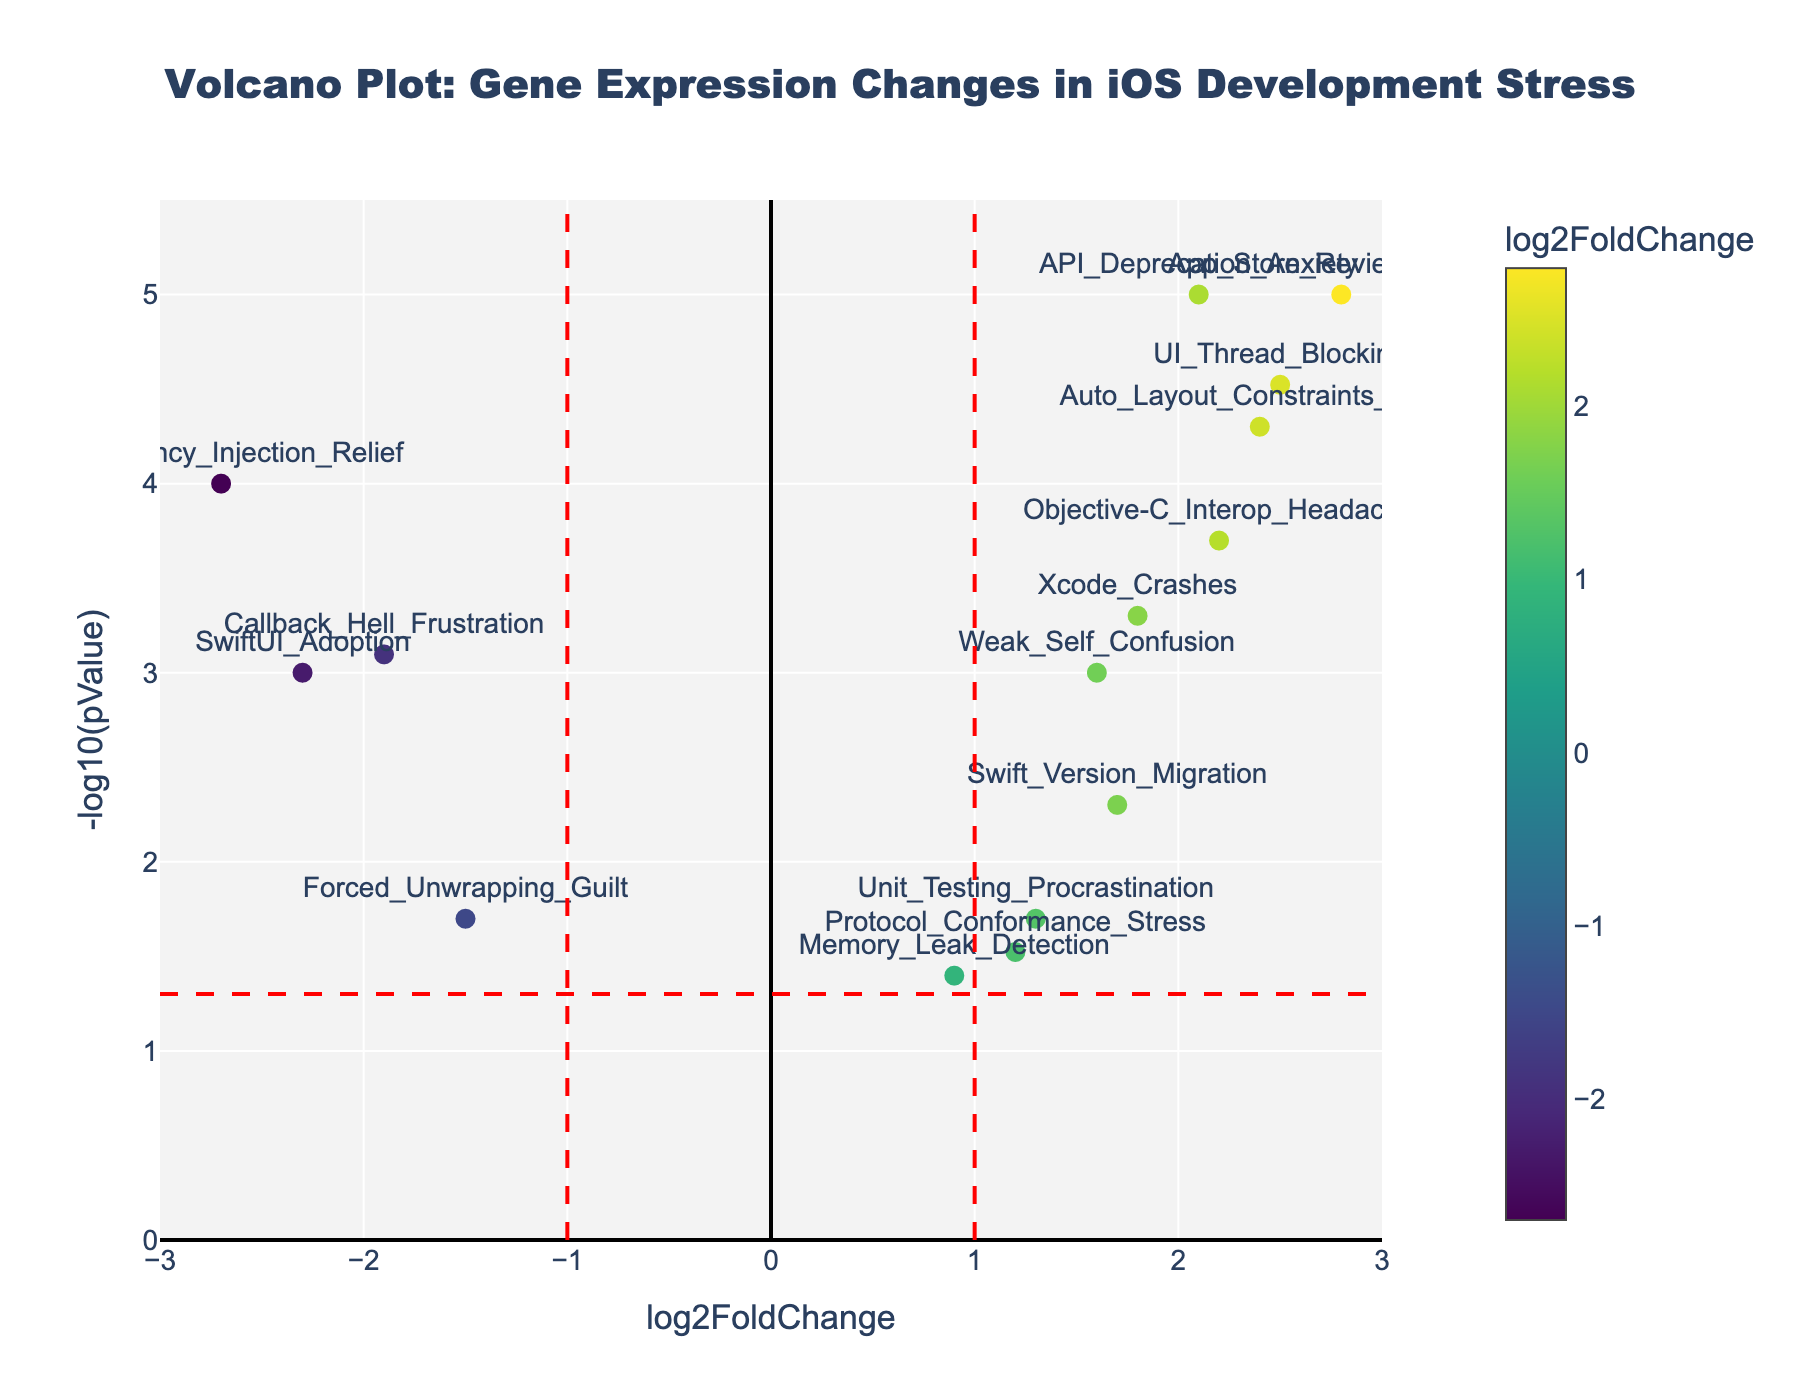What's the title of the figure? The title of the figure is centered at the top and is indicated by the largest and boldest font in the plot.
Answer: Volcano Plot: Gene Expression Changes in iOS Development Stress What are the axes labels and their ranges? The x-axis is labeled as "log2FoldChange" with a range from -3 to 3, and the y-axis is labeled as "-log10(pValue)" with a range from 0 to 5.5. These labels and ranges help to understand the scale and measurements plotted.
Answer: x-axis: log2FoldChange (-3 to 3), y-axis: -log10(pValue) (0 to 5.5) How many data points are plotted on the figure? By counting the number of scatter points visible on the plot, we can determine the number of data points. Each point represents a gene.
Answer: 15 Which gene shows the highest change in expression with the lowest p-value? Identify the point with the highest x-axis value (most extreme log2FoldChange) and highest y-axis value (lowest p-value). The gene with the highest values on both axes is the one we are looking for.
Answer: App_Store_Review_Anxiety Which genes have a log2FoldChange greater than 2? We look for data points that are located at positions greater than 2 on the x-axis and identify the corresponding gene names from the annotations.
Answer: UI_Thread_Blocking, Auto_Layout_Constraints_Panic, App_Store_Review_Anxiety What is the significance threshold applied in the plot for the p-values? The threshold for significance is denoted by a horizontal red dashed line. This line is typically set at -log10(0.05), which corresponds to 1.3 on the y-axis.
Answer: -log10(0.05) ≈ 1.3 Which gene has the most negative log2FoldChange, and what is its significance? Locate the point with the most negative value on the x-axis and check its y-axis value to determine significance. The gene name is annotated near this point.
Answer: Dependency_Injection_Relief, highly significant How many genes have significant changes (p < 0.05) but low fold changes (log2FoldChange between -1 and 1)? Identify data points falling between -1 and 1 on the x-axis and above 1.3 (significance threshold) on the y-axis. Count the number of such points.
Answer: 1 (Memory_Leak_Detection) Which gene has the closest log2FoldChange to zero but is still significant (p < 0.05)? Look for the point nearest to zero on the x-axis and above the 1.3 y-axis threshold, noting the gene name.
Answer: Memory_Leak_Detection 